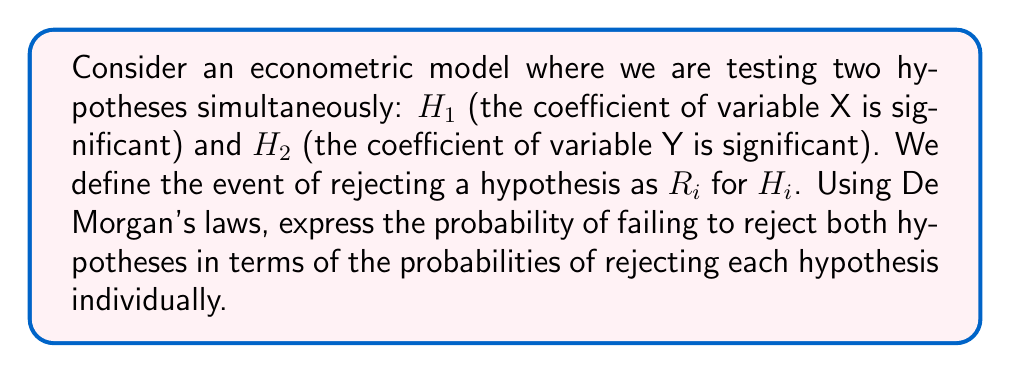Teach me how to tackle this problem. Let's approach this step-by-step:

1) First, we need to understand what it means to fail to reject both hypotheses. This is equivalent to the intersection of the complements of rejecting each hypothesis:

   $P(\text{Fail to reject both}) = P(\overline{R_1} \cap \overline{R_2})$

2) We can apply De Morgan's first law to this expression. De Morgan's first law states that the complement of a union of two sets is equal to the intersection of their complements:

   $\overline{A \cup B} = \overline{A} \cap \overline{B}$

3) Applying this to our problem, we get:

   $P(\overline{R_1} \cap \overline{R_2}) = P(\overline{R_1 \cup R_2})$

4) Now, we can use the complement rule of probability:

   $P(\overline{R_1 \cup R_2}) = 1 - P(R_1 \cup R_2)$

5) Finally, we can use the addition rule of probability:

   $1 - P(R_1 \cup R_2) = 1 - [P(R_1) + P(R_2) - P(R_1 \cap R_2)]$

6) This gives us our final expression in terms of the probabilities of rejecting each hypothesis individually and their joint probability.
Answer: $1 - [P(R_1) + P(R_2) - P(R_1 \cap R_2)]$ 